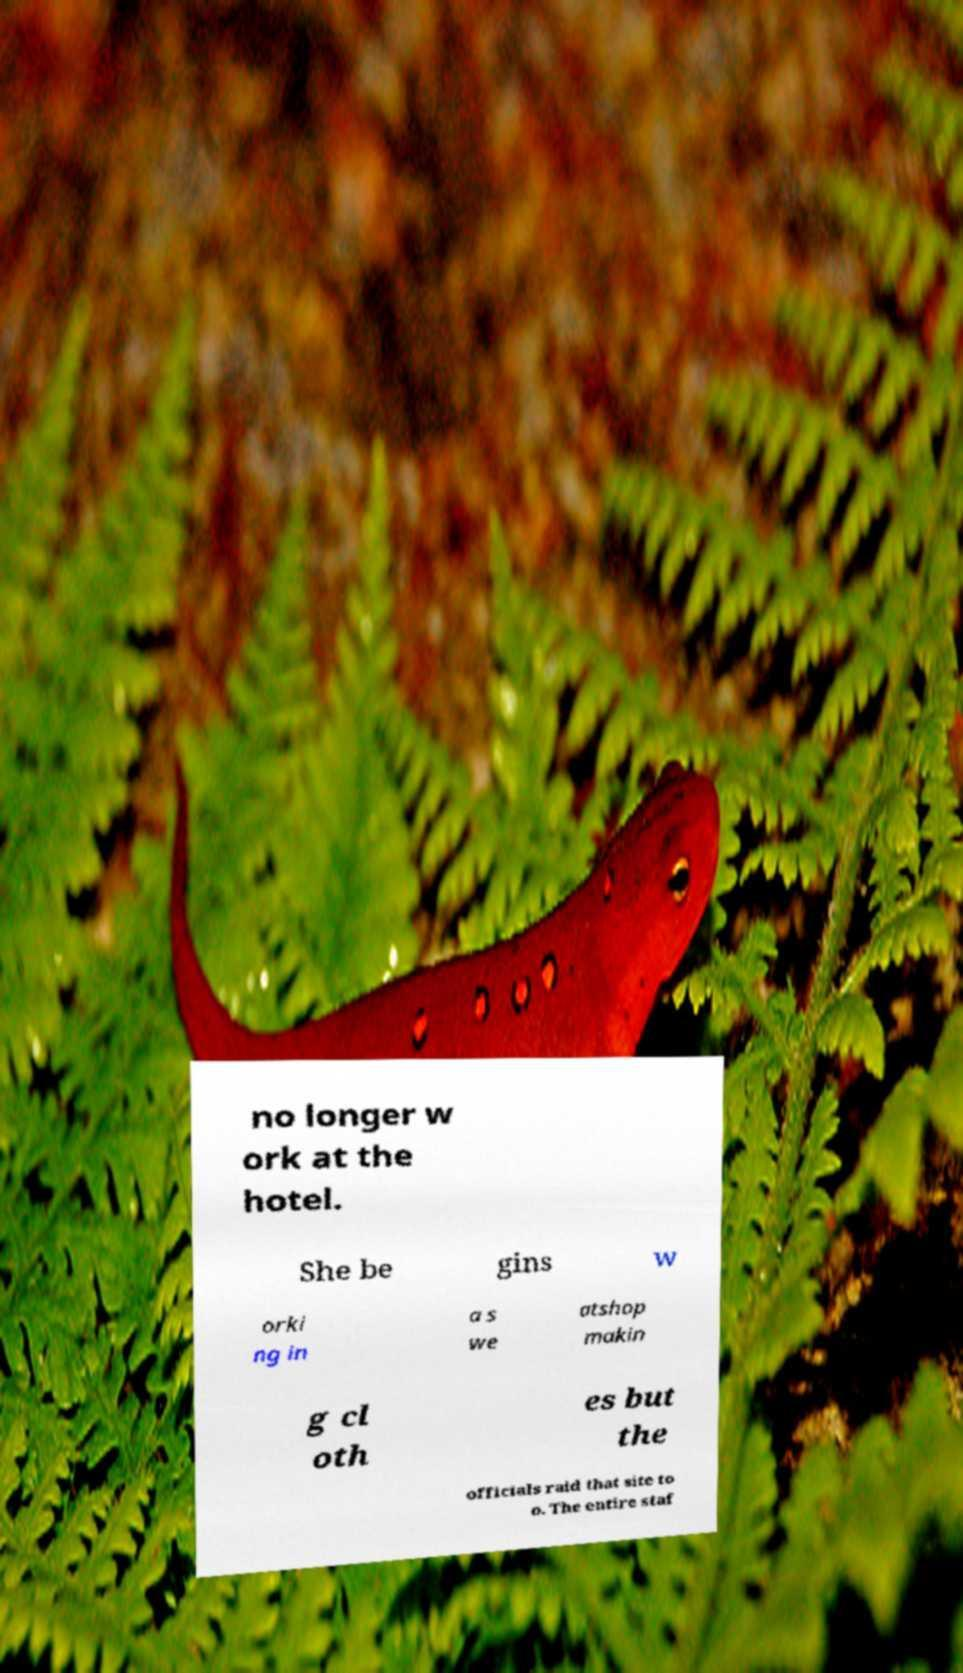Please read and relay the text visible in this image. What does it say? no longer w ork at the hotel. She be gins w orki ng in a s we atshop makin g cl oth es but the officials raid that site to o. The entire staf 